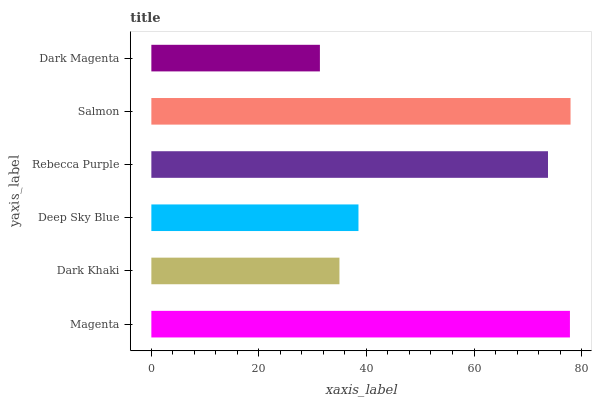Is Dark Magenta the minimum?
Answer yes or no. Yes. Is Salmon the maximum?
Answer yes or no. Yes. Is Dark Khaki the minimum?
Answer yes or no. No. Is Dark Khaki the maximum?
Answer yes or no. No. Is Magenta greater than Dark Khaki?
Answer yes or no. Yes. Is Dark Khaki less than Magenta?
Answer yes or no. Yes. Is Dark Khaki greater than Magenta?
Answer yes or no. No. Is Magenta less than Dark Khaki?
Answer yes or no. No. Is Rebecca Purple the high median?
Answer yes or no. Yes. Is Deep Sky Blue the low median?
Answer yes or no. Yes. Is Deep Sky Blue the high median?
Answer yes or no. No. Is Dark Khaki the low median?
Answer yes or no. No. 